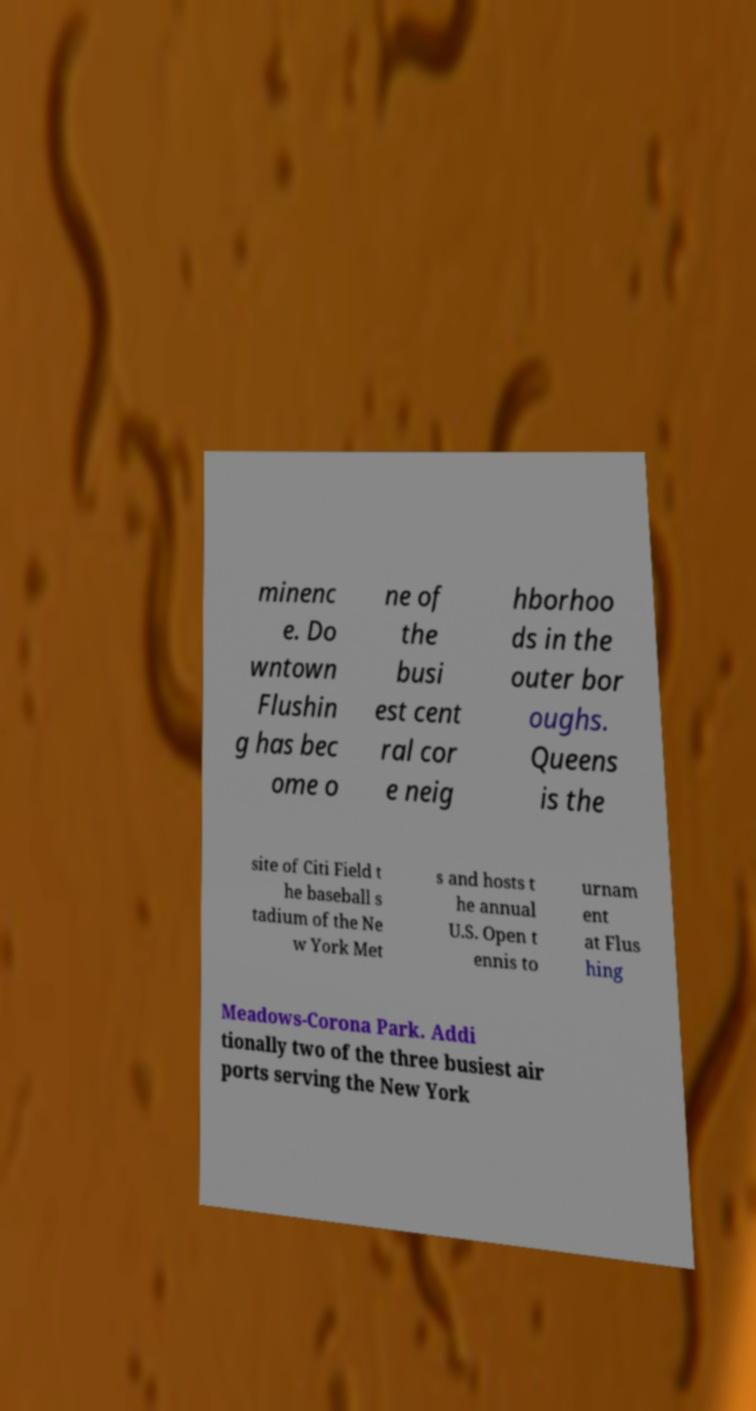Can you read and provide the text displayed in the image?This photo seems to have some interesting text. Can you extract and type it out for me? minenc e. Do wntown Flushin g has bec ome o ne of the busi est cent ral cor e neig hborhoo ds in the outer bor oughs. Queens is the site of Citi Field t he baseball s tadium of the Ne w York Met s and hosts t he annual U.S. Open t ennis to urnam ent at Flus hing Meadows-Corona Park. Addi tionally two of the three busiest air ports serving the New York 